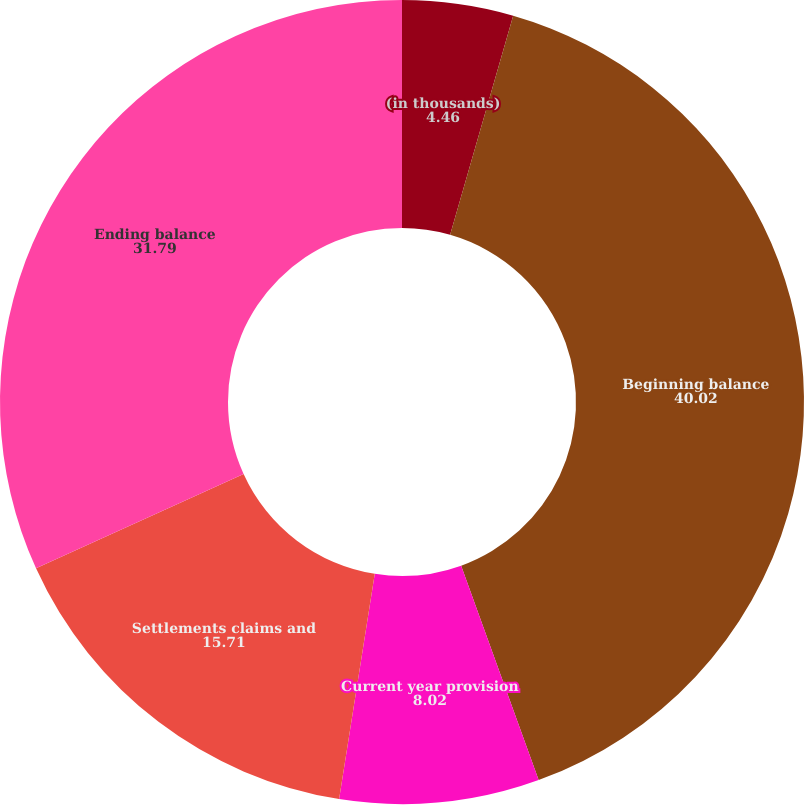Convert chart to OTSL. <chart><loc_0><loc_0><loc_500><loc_500><pie_chart><fcel>(in thousands)<fcel>Beginning balance<fcel>Current year provision<fcel>Settlements claims and<fcel>Ending balance<nl><fcel>4.46%<fcel>40.02%<fcel>8.02%<fcel>15.71%<fcel>31.79%<nl></chart> 